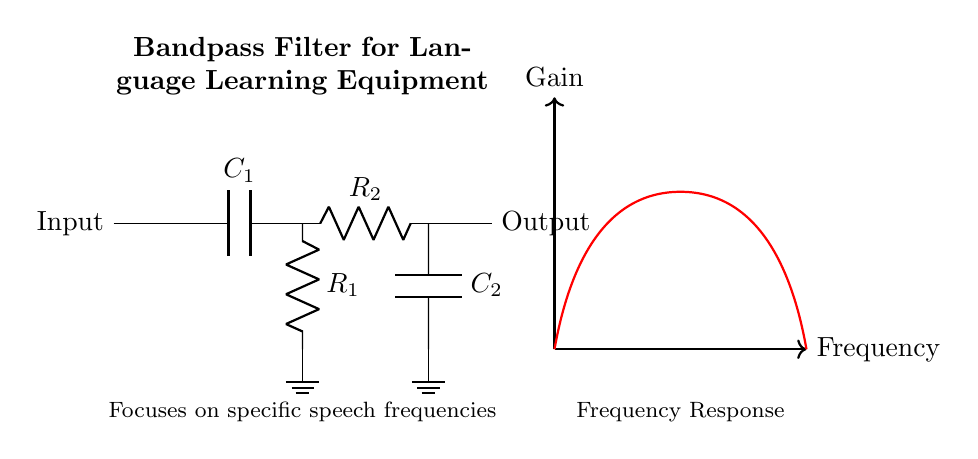What type of filter is represented in the circuit? The circuit diagram shows a bandpass filter, which is designed to allow frequencies within a certain range to pass through while attenuating frequencies outside of that range. This is indicated by the combination of high-pass and low-pass filter components.
Answer: bandpass filter What are the values of the capacitors in the circuit? The circuit features two capacitors, C1 and C2; however, the specific capacitance values are not provided in the diagram. They must be predetermined based on the design requirements for the frequency range.
Answer: Not specified How many resistors are present in this circuit? The circuit contains two resistors, R1 and R2, one for each filtering section (high-pass and low-pass). This can be identified by checking the connections and labeling within the diagram.
Answer: two What component is connected in series with C1? The resistor R1 is directly connected in series with the capacitor C1. In the high-pass filter section, C1 is placed first, followed by R1, which leads to the ground node, completing the high-pass filter configuration.
Answer: R1 What is the purpose of the circuit as it relates to language learning? The purpose of the bandpass filter in this context is to focus on specific speech frequencies, which can help in improving speech intelligibility and enhancing language learning. This is explicitly noted in the annotations provided on the diagram.
Answer: Focus on speech frequencies What do the two sections (high-pass and low-pass) of the circuit achieve? The high-pass section allows higher frequencies to pass while attenuating low ones, whereas the low-pass section allows low frequencies to pass and attenuates high ones. Together, they define the bandwidth of the bandpass filter, affecting which speech frequencies are enhanced or diminished.
Answer: Define bandwidth 